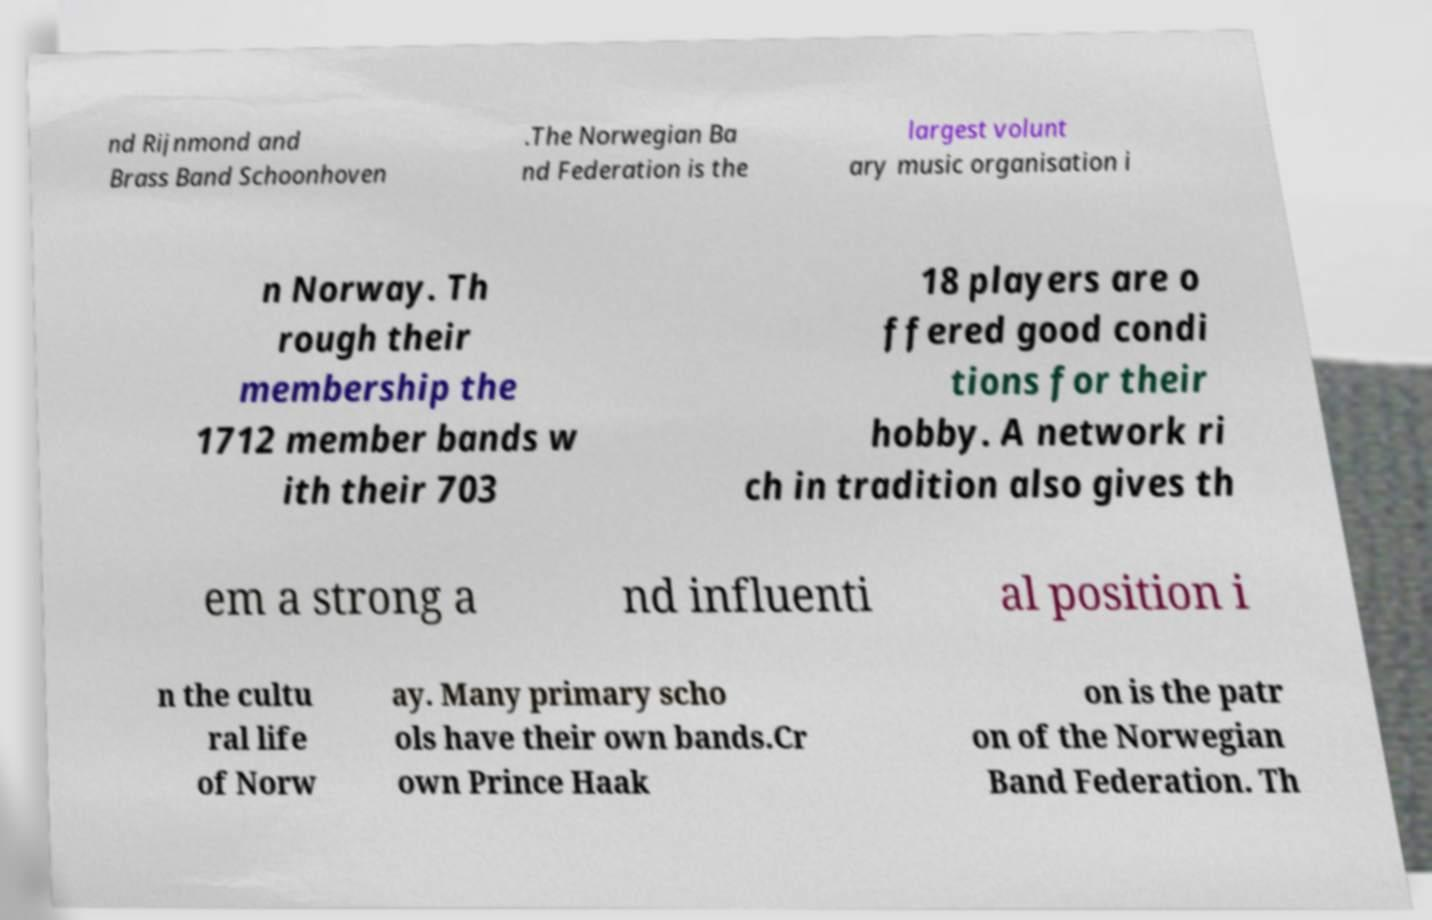Please identify and transcribe the text found in this image. nd Rijnmond and Brass Band Schoonhoven .The Norwegian Ba nd Federation is the largest volunt ary music organisation i n Norway. Th rough their membership the 1712 member bands w ith their 703 18 players are o ffered good condi tions for their hobby. A network ri ch in tradition also gives th em a strong a nd influenti al position i n the cultu ral life of Norw ay. Many primary scho ols have their own bands.Cr own Prince Haak on is the patr on of the Norwegian Band Federation. Th 